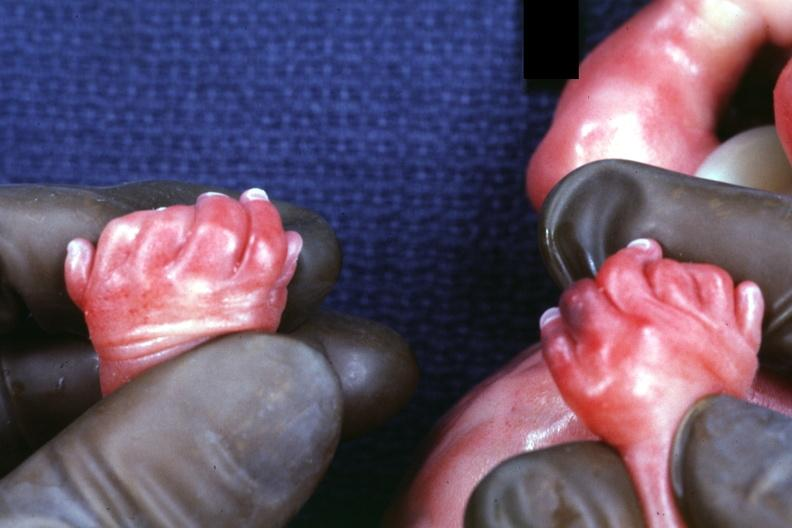s six digits and syndactyly present?
Answer the question using a single word or phrase. Six 